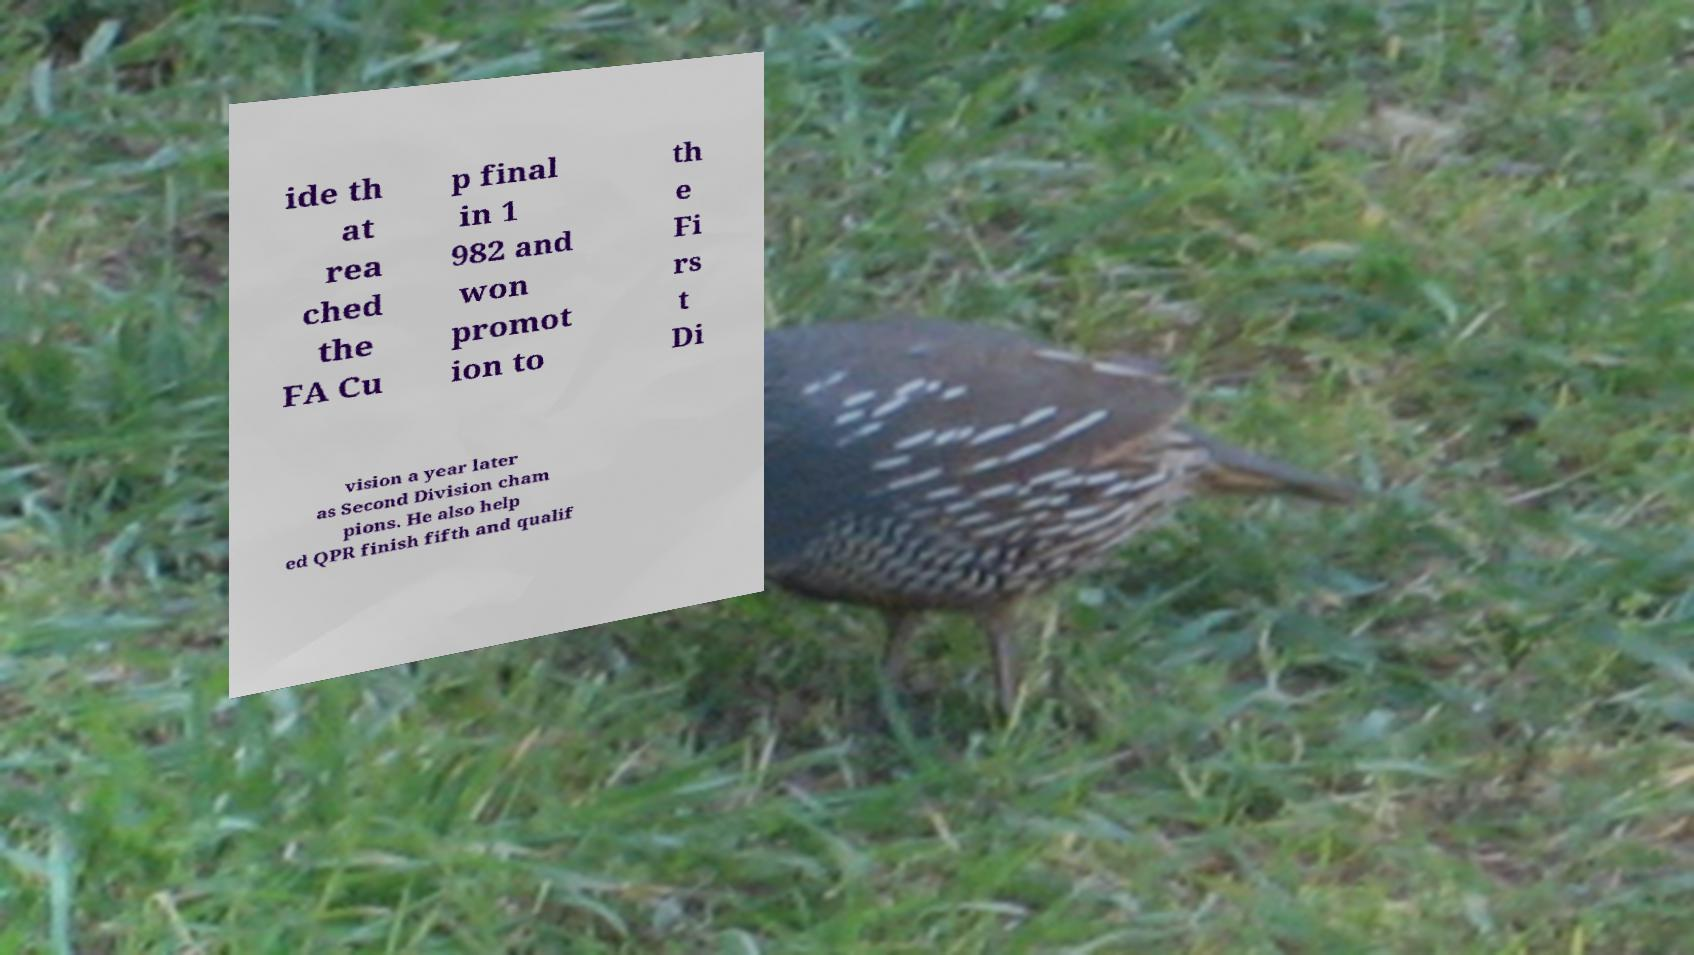For documentation purposes, I need the text within this image transcribed. Could you provide that? ide th at rea ched the FA Cu p final in 1 982 and won promot ion to th e Fi rs t Di vision a year later as Second Division cham pions. He also help ed QPR finish fifth and qualif 